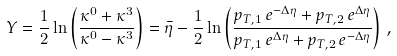<formula> <loc_0><loc_0><loc_500><loc_500>Y = \frac { 1 } { 2 } \ln \left ( \frac { \kappa ^ { 0 } + \kappa ^ { 3 } } { \kappa ^ { 0 } - \kappa ^ { 3 } } \right ) = \bar { \eta } - \frac { 1 } { 2 } \ln \left ( \frac { p _ { T , 1 } \, { e } ^ { - \Delta \eta } + p _ { T , 2 } \, { e } ^ { \Delta \eta } } { p _ { T , 1 } \, { e } ^ { \Delta \eta } + p _ { T , 2 } \, { e } ^ { - \Delta \eta } } \right ) \, ,</formula> 